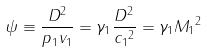<formula> <loc_0><loc_0><loc_500><loc_500>\psi \equiv \frac { D ^ { 2 } } { { p } _ { 1 } { v } _ { 1 } } = { \gamma _ { 1 } } \frac { D ^ { 2 } } { { c _ { 1 } } ^ { 2 } } = { \gamma _ { 1 } } { { M _ { 1 } } ^ { 2 } }</formula> 